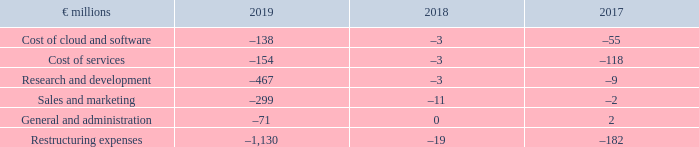If not presented separately in our income statement, restructuring expenses would have been classified in the different expense items in our income statement as follows:
Restructuring Expenses by Functional Area
What was the Cost of services in 2019?
Answer scale should be: million. –154. What was the Research and development in 2019?
Answer scale should be: million. –467. In which years are Restructuring Expenses by Functional Area calculated? 2019, 2018, 2017. In which year was Cost of services largest? |-154|>|-118|>|-3|
Answer: 2019. What was the change in General and administration in 2018 from 2017?
Answer scale should be: million. 0-2
Answer: -2. What was the percentage change in General and administration in 2018 from 2017?
Answer scale should be: percent. (0-2)/2
Answer: -100. 